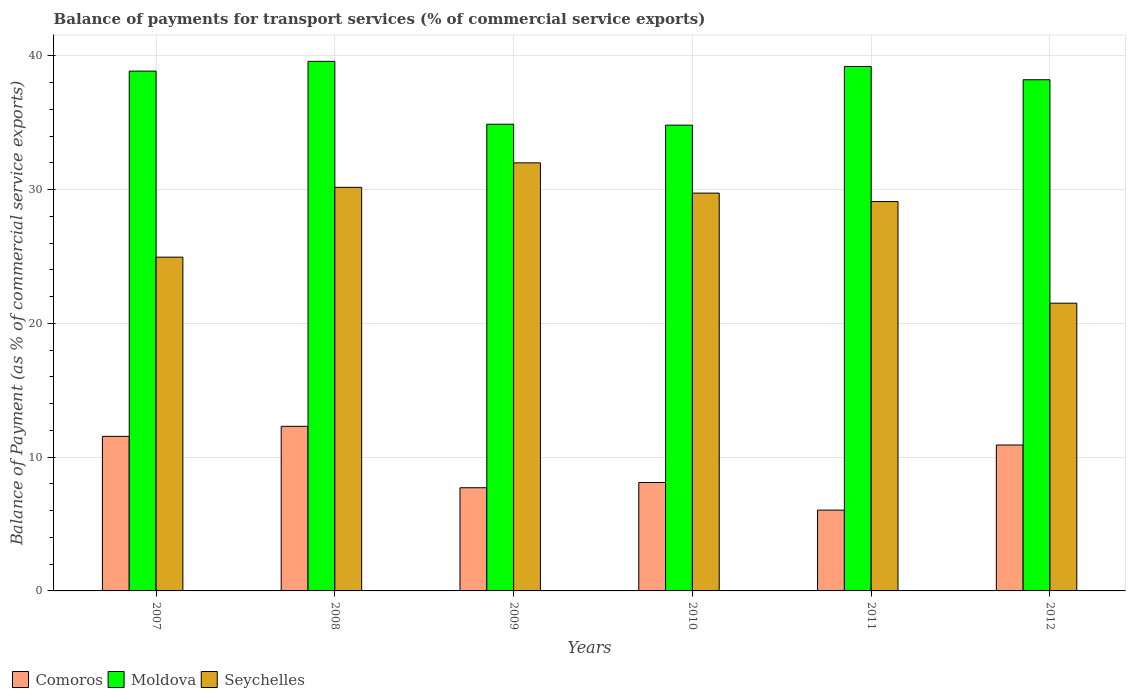How many different coloured bars are there?
Your answer should be compact. 3. How many bars are there on the 3rd tick from the left?
Your answer should be very brief. 3. What is the label of the 4th group of bars from the left?
Your answer should be compact. 2010. What is the balance of payments for transport services in Comoros in 2009?
Your answer should be very brief. 7.71. Across all years, what is the maximum balance of payments for transport services in Seychelles?
Offer a very short reply. 32. Across all years, what is the minimum balance of payments for transport services in Comoros?
Give a very brief answer. 6.04. In which year was the balance of payments for transport services in Moldova maximum?
Offer a terse response. 2008. What is the total balance of payments for transport services in Seychelles in the graph?
Give a very brief answer. 167.48. What is the difference between the balance of payments for transport services in Moldova in 2010 and that in 2011?
Your response must be concise. -4.39. What is the difference between the balance of payments for transport services in Moldova in 2008 and the balance of payments for transport services in Seychelles in 2009?
Your answer should be very brief. 7.59. What is the average balance of payments for transport services in Comoros per year?
Make the answer very short. 9.44. In the year 2012, what is the difference between the balance of payments for transport services in Seychelles and balance of payments for transport services in Moldova?
Your answer should be compact. -16.7. In how many years, is the balance of payments for transport services in Moldova greater than 4 %?
Provide a succinct answer. 6. What is the ratio of the balance of payments for transport services in Comoros in 2009 to that in 2011?
Provide a short and direct response. 1.28. What is the difference between the highest and the second highest balance of payments for transport services in Comoros?
Ensure brevity in your answer.  0.75. What is the difference between the highest and the lowest balance of payments for transport services in Comoros?
Give a very brief answer. 6.26. In how many years, is the balance of payments for transport services in Moldova greater than the average balance of payments for transport services in Moldova taken over all years?
Make the answer very short. 4. What does the 3rd bar from the left in 2010 represents?
Give a very brief answer. Seychelles. What does the 3rd bar from the right in 2012 represents?
Provide a short and direct response. Comoros. How many bars are there?
Your answer should be compact. 18. How many years are there in the graph?
Provide a short and direct response. 6. What is the difference between two consecutive major ticks on the Y-axis?
Your response must be concise. 10. Are the values on the major ticks of Y-axis written in scientific E-notation?
Your response must be concise. No. Does the graph contain any zero values?
Keep it short and to the point. No. Does the graph contain grids?
Offer a terse response. Yes. Where does the legend appear in the graph?
Provide a short and direct response. Bottom left. How many legend labels are there?
Ensure brevity in your answer.  3. What is the title of the graph?
Offer a terse response. Balance of payments for transport services (% of commercial service exports). What is the label or title of the X-axis?
Your response must be concise. Years. What is the label or title of the Y-axis?
Make the answer very short. Balance of Payment (as % of commercial service exports). What is the Balance of Payment (as % of commercial service exports) of Comoros in 2007?
Offer a terse response. 11.56. What is the Balance of Payment (as % of commercial service exports) of Moldova in 2007?
Ensure brevity in your answer.  38.86. What is the Balance of Payment (as % of commercial service exports) of Seychelles in 2007?
Make the answer very short. 24.95. What is the Balance of Payment (as % of commercial service exports) of Comoros in 2008?
Your answer should be very brief. 12.31. What is the Balance of Payment (as % of commercial service exports) in Moldova in 2008?
Provide a short and direct response. 39.59. What is the Balance of Payment (as % of commercial service exports) of Seychelles in 2008?
Your response must be concise. 30.17. What is the Balance of Payment (as % of commercial service exports) of Comoros in 2009?
Offer a terse response. 7.71. What is the Balance of Payment (as % of commercial service exports) in Moldova in 2009?
Keep it short and to the point. 34.89. What is the Balance of Payment (as % of commercial service exports) in Seychelles in 2009?
Ensure brevity in your answer.  32. What is the Balance of Payment (as % of commercial service exports) in Comoros in 2010?
Your answer should be very brief. 8.1. What is the Balance of Payment (as % of commercial service exports) of Moldova in 2010?
Your answer should be very brief. 34.82. What is the Balance of Payment (as % of commercial service exports) of Seychelles in 2010?
Provide a succinct answer. 29.74. What is the Balance of Payment (as % of commercial service exports) of Comoros in 2011?
Your answer should be very brief. 6.04. What is the Balance of Payment (as % of commercial service exports) of Moldova in 2011?
Offer a very short reply. 39.21. What is the Balance of Payment (as % of commercial service exports) in Seychelles in 2011?
Provide a succinct answer. 29.11. What is the Balance of Payment (as % of commercial service exports) in Comoros in 2012?
Provide a succinct answer. 10.91. What is the Balance of Payment (as % of commercial service exports) in Moldova in 2012?
Make the answer very short. 38.22. What is the Balance of Payment (as % of commercial service exports) of Seychelles in 2012?
Provide a short and direct response. 21.51. Across all years, what is the maximum Balance of Payment (as % of commercial service exports) of Comoros?
Give a very brief answer. 12.31. Across all years, what is the maximum Balance of Payment (as % of commercial service exports) of Moldova?
Give a very brief answer. 39.59. Across all years, what is the maximum Balance of Payment (as % of commercial service exports) of Seychelles?
Your answer should be compact. 32. Across all years, what is the minimum Balance of Payment (as % of commercial service exports) of Comoros?
Provide a succinct answer. 6.04. Across all years, what is the minimum Balance of Payment (as % of commercial service exports) in Moldova?
Provide a succinct answer. 34.82. Across all years, what is the minimum Balance of Payment (as % of commercial service exports) of Seychelles?
Keep it short and to the point. 21.51. What is the total Balance of Payment (as % of commercial service exports) in Comoros in the graph?
Make the answer very short. 56.63. What is the total Balance of Payment (as % of commercial service exports) in Moldova in the graph?
Your answer should be very brief. 225.59. What is the total Balance of Payment (as % of commercial service exports) in Seychelles in the graph?
Your answer should be very brief. 167.48. What is the difference between the Balance of Payment (as % of commercial service exports) in Comoros in 2007 and that in 2008?
Your answer should be compact. -0.75. What is the difference between the Balance of Payment (as % of commercial service exports) in Moldova in 2007 and that in 2008?
Make the answer very short. -0.73. What is the difference between the Balance of Payment (as % of commercial service exports) in Seychelles in 2007 and that in 2008?
Ensure brevity in your answer.  -5.22. What is the difference between the Balance of Payment (as % of commercial service exports) of Comoros in 2007 and that in 2009?
Keep it short and to the point. 3.84. What is the difference between the Balance of Payment (as % of commercial service exports) of Moldova in 2007 and that in 2009?
Your response must be concise. 3.97. What is the difference between the Balance of Payment (as % of commercial service exports) of Seychelles in 2007 and that in 2009?
Make the answer very short. -7.05. What is the difference between the Balance of Payment (as % of commercial service exports) in Comoros in 2007 and that in 2010?
Keep it short and to the point. 3.45. What is the difference between the Balance of Payment (as % of commercial service exports) in Moldova in 2007 and that in 2010?
Make the answer very short. 4.04. What is the difference between the Balance of Payment (as % of commercial service exports) of Seychelles in 2007 and that in 2010?
Give a very brief answer. -4.79. What is the difference between the Balance of Payment (as % of commercial service exports) of Comoros in 2007 and that in 2011?
Offer a terse response. 5.51. What is the difference between the Balance of Payment (as % of commercial service exports) in Moldova in 2007 and that in 2011?
Offer a terse response. -0.35. What is the difference between the Balance of Payment (as % of commercial service exports) of Seychelles in 2007 and that in 2011?
Ensure brevity in your answer.  -4.16. What is the difference between the Balance of Payment (as % of commercial service exports) in Comoros in 2007 and that in 2012?
Your response must be concise. 0.65. What is the difference between the Balance of Payment (as % of commercial service exports) in Moldova in 2007 and that in 2012?
Offer a terse response. 0.65. What is the difference between the Balance of Payment (as % of commercial service exports) in Seychelles in 2007 and that in 2012?
Offer a terse response. 3.44. What is the difference between the Balance of Payment (as % of commercial service exports) in Comoros in 2008 and that in 2009?
Provide a succinct answer. 4.59. What is the difference between the Balance of Payment (as % of commercial service exports) of Moldova in 2008 and that in 2009?
Provide a succinct answer. 4.7. What is the difference between the Balance of Payment (as % of commercial service exports) of Seychelles in 2008 and that in 2009?
Your answer should be compact. -1.83. What is the difference between the Balance of Payment (as % of commercial service exports) of Comoros in 2008 and that in 2010?
Provide a short and direct response. 4.2. What is the difference between the Balance of Payment (as % of commercial service exports) of Moldova in 2008 and that in 2010?
Keep it short and to the point. 4.77. What is the difference between the Balance of Payment (as % of commercial service exports) of Seychelles in 2008 and that in 2010?
Offer a very short reply. 0.43. What is the difference between the Balance of Payment (as % of commercial service exports) of Comoros in 2008 and that in 2011?
Make the answer very short. 6.26. What is the difference between the Balance of Payment (as % of commercial service exports) of Moldova in 2008 and that in 2011?
Make the answer very short. 0.38. What is the difference between the Balance of Payment (as % of commercial service exports) in Seychelles in 2008 and that in 2011?
Your response must be concise. 1.06. What is the difference between the Balance of Payment (as % of commercial service exports) in Comoros in 2008 and that in 2012?
Offer a terse response. 1.4. What is the difference between the Balance of Payment (as % of commercial service exports) of Moldova in 2008 and that in 2012?
Your response must be concise. 1.37. What is the difference between the Balance of Payment (as % of commercial service exports) of Seychelles in 2008 and that in 2012?
Your response must be concise. 8.66. What is the difference between the Balance of Payment (as % of commercial service exports) in Comoros in 2009 and that in 2010?
Offer a terse response. -0.39. What is the difference between the Balance of Payment (as % of commercial service exports) of Moldova in 2009 and that in 2010?
Keep it short and to the point. 0.07. What is the difference between the Balance of Payment (as % of commercial service exports) in Seychelles in 2009 and that in 2010?
Offer a terse response. 2.26. What is the difference between the Balance of Payment (as % of commercial service exports) of Comoros in 2009 and that in 2011?
Offer a very short reply. 1.67. What is the difference between the Balance of Payment (as % of commercial service exports) of Moldova in 2009 and that in 2011?
Your answer should be very brief. -4.32. What is the difference between the Balance of Payment (as % of commercial service exports) of Seychelles in 2009 and that in 2011?
Give a very brief answer. 2.89. What is the difference between the Balance of Payment (as % of commercial service exports) in Comoros in 2009 and that in 2012?
Give a very brief answer. -3.19. What is the difference between the Balance of Payment (as % of commercial service exports) of Moldova in 2009 and that in 2012?
Make the answer very short. -3.33. What is the difference between the Balance of Payment (as % of commercial service exports) in Seychelles in 2009 and that in 2012?
Your answer should be very brief. 10.49. What is the difference between the Balance of Payment (as % of commercial service exports) in Comoros in 2010 and that in 2011?
Your response must be concise. 2.06. What is the difference between the Balance of Payment (as % of commercial service exports) of Moldova in 2010 and that in 2011?
Make the answer very short. -4.39. What is the difference between the Balance of Payment (as % of commercial service exports) in Seychelles in 2010 and that in 2011?
Keep it short and to the point. 0.63. What is the difference between the Balance of Payment (as % of commercial service exports) in Comoros in 2010 and that in 2012?
Offer a very short reply. -2.8. What is the difference between the Balance of Payment (as % of commercial service exports) of Moldova in 2010 and that in 2012?
Ensure brevity in your answer.  -3.39. What is the difference between the Balance of Payment (as % of commercial service exports) in Seychelles in 2010 and that in 2012?
Offer a terse response. 8.23. What is the difference between the Balance of Payment (as % of commercial service exports) in Comoros in 2011 and that in 2012?
Provide a succinct answer. -4.87. What is the difference between the Balance of Payment (as % of commercial service exports) in Moldova in 2011 and that in 2012?
Make the answer very short. 0.99. What is the difference between the Balance of Payment (as % of commercial service exports) of Seychelles in 2011 and that in 2012?
Your answer should be very brief. 7.6. What is the difference between the Balance of Payment (as % of commercial service exports) in Comoros in 2007 and the Balance of Payment (as % of commercial service exports) in Moldova in 2008?
Provide a succinct answer. -28.03. What is the difference between the Balance of Payment (as % of commercial service exports) in Comoros in 2007 and the Balance of Payment (as % of commercial service exports) in Seychelles in 2008?
Give a very brief answer. -18.62. What is the difference between the Balance of Payment (as % of commercial service exports) in Moldova in 2007 and the Balance of Payment (as % of commercial service exports) in Seychelles in 2008?
Provide a succinct answer. 8.69. What is the difference between the Balance of Payment (as % of commercial service exports) of Comoros in 2007 and the Balance of Payment (as % of commercial service exports) of Moldova in 2009?
Give a very brief answer. -23.33. What is the difference between the Balance of Payment (as % of commercial service exports) of Comoros in 2007 and the Balance of Payment (as % of commercial service exports) of Seychelles in 2009?
Your answer should be compact. -20.45. What is the difference between the Balance of Payment (as % of commercial service exports) of Moldova in 2007 and the Balance of Payment (as % of commercial service exports) of Seychelles in 2009?
Provide a succinct answer. 6.86. What is the difference between the Balance of Payment (as % of commercial service exports) of Comoros in 2007 and the Balance of Payment (as % of commercial service exports) of Moldova in 2010?
Your answer should be compact. -23.27. What is the difference between the Balance of Payment (as % of commercial service exports) in Comoros in 2007 and the Balance of Payment (as % of commercial service exports) in Seychelles in 2010?
Offer a terse response. -18.18. What is the difference between the Balance of Payment (as % of commercial service exports) of Moldova in 2007 and the Balance of Payment (as % of commercial service exports) of Seychelles in 2010?
Your answer should be compact. 9.12. What is the difference between the Balance of Payment (as % of commercial service exports) of Comoros in 2007 and the Balance of Payment (as % of commercial service exports) of Moldova in 2011?
Provide a short and direct response. -27.65. What is the difference between the Balance of Payment (as % of commercial service exports) in Comoros in 2007 and the Balance of Payment (as % of commercial service exports) in Seychelles in 2011?
Keep it short and to the point. -17.55. What is the difference between the Balance of Payment (as % of commercial service exports) in Moldova in 2007 and the Balance of Payment (as % of commercial service exports) in Seychelles in 2011?
Your answer should be very brief. 9.75. What is the difference between the Balance of Payment (as % of commercial service exports) in Comoros in 2007 and the Balance of Payment (as % of commercial service exports) in Moldova in 2012?
Your answer should be compact. -26.66. What is the difference between the Balance of Payment (as % of commercial service exports) in Comoros in 2007 and the Balance of Payment (as % of commercial service exports) in Seychelles in 2012?
Your answer should be compact. -9.96. What is the difference between the Balance of Payment (as % of commercial service exports) of Moldova in 2007 and the Balance of Payment (as % of commercial service exports) of Seychelles in 2012?
Provide a short and direct response. 17.35. What is the difference between the Balance of Payment (as % of commercial service exports) in Comoros in 2008 and the Balance of Payment (as % of commercial service exports) in Moldova in 2009?
Keep it short and to the point. -22.58. What is the difference between the Balance of Payment (as % of commercial service exports) in Comoros in 2008 and the Balance of Payment (as % of commercial service exports) in Seychelles in 2009?
Offer a terse response. -19.7. What is the difference between the Balance of Payment (as % of commercial service exports) of Moldova in 2008 and the Balance of Payment (as % of commercial service exports) of Seychelles in 2009?
Offer a terse response. 7.59. What is the difference between the Balance of Payment (as % of commercial service exports) of Comoros in 2008 and the Balance of Payment (as % of commercial service exports) of Moldova in 2010?
Offer a terse response. -22.52. What is the difference between the Balance of Payment (as % of commercial service exports) in Comoros in 2008 and the Balance of Payment (as % of commercial service exports) in Seychelles in 2010?
Give a very brief answer. -17.43. What is the difference between the Balance of Payment (as % of commercial service exports) of Moldova in 2008 and the Balance of Payment (as % of commercial service exports) of Seychelles in 2010?
Your response must be concise. 9.85. What is the difference between the Balance of Payment (as % of commercial service exports) in Comoros in 2008 and the Balance of Payment (as % of commercial service exports) in Moldova in 2011?
Keep it short and to the point. -26.9. What is the difference between the Balance of Payment (as % of commercial service exports) of Comoros in 2008 and the Balance of Payment (as % of commercial service exports) of Seychelles in 2011?
Offer a terse response. -16.8. What is the difference between the Balance of Payment (as % of commercial service exports) of Moldova in 2008 and the Balance of Payment (as % of commercial service exports) of Seychelles in 2011?
Ensure brevity in your answer.  10.48. What is the difference between the Balance of Payment (as % of commercial service exports) of Comoros in 2008 and the Balance of Payment (as % of commercial service exports) of Moldova in 2012?
Offer a very short reply. -25.91. What is the difference between the Balance of Payment (as % of commercial service exports) of Comoros in 2008 and the Balance of Payment (as % of commercial service exports) of Seychelles in 2012?
Give a very brief answer. -9.21. What is the difference between the Balance of Payment (as % of commercial service exports) of Moldova in 2008 and the Balance of Payment (as % of commercial service exports) of Seychelles in 2012?
Your response must be concise. 18.08. What is the difference between the Balance of Payment (as % of commercial service exports) in Comoros in 2009 and the Balance of Payment (as % of commercial service exports) in Moldova in 2010?
Your answer should be very brief. -27.11. What is the difference between the Balance of Payment (as % of commercial service exports) of Comoros in 2009 and the Balance of Payment (as % of commercial service exports) of Seychelles in 2010?
Your answer should be very brief. -22.03. What is the difference between the Balance of Payment (as % of commercial service exports) of Moldova in 2009 and the Balance of Payment (as % of commercial service exports) of Seychelles in 2010?
Offer a very short reply. 5.15. What is the difference between the Balance of Payment (as % of commercial service exports) in Comoros in 2009 and the Balance of Payment (as % of commercial service exports) in Moldova in 2011?
Give a very brief answer. -31.49. What is the difference between the Balance of Payment (as % of commercial service exports) in Comoros in 2009 and the Balance of Payment (as % of commercial service exports) in Seychelles in 2011?
Your response must be concise. -21.4. What is the difference between the Balance of Payment (as % of commercial service exports) of Moldova in 2009 and the Balance of Payment (as % of commercial service exports) of Seychelles in 2011?
Give a very brief answer. 5.78. What is the difference between the Balance of Payment (as % of commercial service exports) of Comoros in 2009 and the Balance of Payment (as % of commercial service exports) of Moldova in 2012?
Your answer should be compact. -30.5. What is the difference between the Balance of Payment (as % of commercial service exports) of Comoros in 2009 and the Balance of Payment (as % of commercial service exports) of Seychelles in 2012?
Give a very brief answer. -13.8. What is the difference between the Balance of Payment (as % of commercial service exports) in Moldova in 2009 and the Balance of Payment (as % of commercial service exports) in Seychelles in 2012?
Make the answer very short. 13.38. What is the difference between the Balance of Payment (as % of commercial service exports) of Comoros in 2010 and the Balance of Payment (as % of commercial service exports) of Moldova in 2011?
Offer a very short reply. -31.1. What is the difference between the Balance of Payment (as % of commercial service exports) in Comoros in 2010 and the Balance of Payment (as % of commercial service exports) in Seychelles in 2011?
Your answer should be compact. -21. What is the difference between the Balance of Payment (as % of commercial service exports) of Moldova in 2010 and the Balance of Payment (as % of commercial service exports) of Seychelles in 2011?
Provide a short and direct response. 5.71. What is the difference between the Balance of Payment (as % of commercial service exports) in Comoros in 2010 and the Balance of Payment (as % of commercial service exports) in Moldova in 2012?
Your response must be concise. -30.11. What is the difference between the Balance of Payment (as % of commercial service exports) in Comoros in 2010 and the Balance of Payment (as % of commercial service exports) in Seychelles in 2012?
Provide a short and direct response. -13.41. What is the difference between the Balance of Payment (as % of commercial service exports) of Moldova in 2010 and the Balance of Payment (as % of commercial service exports) of Seychelles in 2012?
Provide a succinct answer. 13.31. What is the difference between the Balance of Payment (as % of commercial service exports) in Comoros in 2011 and the Balance of Payment (as % of commercial service exports) in Moldova in 2012?
Ensure brevity in your answer.  -32.17. What is the difference between the Balance of Payment (as % of commercial service exports) of Comoros in 2011 and the Balance of Payment (as % of commercial service exports) of Seychelles in 2012?
Provide a short and direct response. -15.47. What is the difference between the Balance of Payment (as % of commercial service exports) in Moldova in 2011 and the Balance of Payment (as % of commercial service exports) in Seychelles in 2012?
Your response must be concise. 17.7. What is the average Balance of Payment (as % of commercial service exports) of Comoros per year?
Provide a succinct answer. 9.44. What is the average Balance of Payment (as % of commercial service exports) of Moldova per year?
Your answer should be very brief. 37.6. What is the average Balance of Payment (as % of commercial service exports) in Seychelles per year?
Your answer should be very brief. 27.91. In the year 2007, what is the difference between the Balance of Payment (as % of commercial service exports) in Comoros and Balance of Payment (as % of commercial service exports) in Moldova?
Provide a short and direct response. -27.31. In the year 2007, what is the difference between the Balance of Payment (as % of commercial service exports) in Comoros and Balance of Payment (as % of commercial service exports) in Seychelles?
Provide a short and direct response. -13.4. In the year 2007, what is the difference between the Balance of Payment (as % of commercial service exports) in Moldova and Balance of Payment (as % of commercial service exports) in Seychelles?
Your response must be concise. 13.91. In the year 2008, what is the difference between the Balance of Payment (as % of commercial service exports) in Comoros and Balance of Payment (as % of commercial service exports) in Moldova?
Offer a very short reply. -27.28. In the year 2008, what is the difference between the Balance of Payment (as % of commercial service exports) of Comoros and Balance of Payment (as % of commercial service exports) of Seychelles?
Your response must be concise. -17.87. In the year 2008, what is the difference between the Balance of Payment (as % of commercial service exports) in Moldova and Balance of Payment (as % of commercial service exports) in Seychelles?
Your answer should be very brief. 9.42. In the year 2009, what is the difference between the Balance of Payment (as % of commercial service exports) in Comoros and Balance of Payment (as % of commercial service exports) in Moldova?
Give a very brief answer. -27.18. In the year 2009, what is the difference between the Balance of Payment (as % of commercial service exports) in Comoros and Balance of Payment (as % of commercial service exports) in Seychelles?
Give a very brief answer. -24.29. In the year 2009, what is the difference between the Balance of Payment (as % of commercial service exports) in Moldova and Balance of Payment (as % of commercial service exports) in Seychelles?
Offer a terse response. 2.89. In the year 2010, what is the difference between the Balance of Payment (as % of commercial service exports) in Comoros and Balance of Payment (as % of commercial service exports) in Moldova?
Offer a terse response. -26.72. In the year 2010, what is the difference between the Balance of Payment (as % of commercial service exports) in Comoros and Balance of Payment (as % of commercial service exports) in Seychelles?
Ensure brevity in your answer.  -21.63. In the year 2010, what is the difference between the Balance of Payment (as % of commercial service exports) in Moldova and Balance of Payment (as % of commercial service exports) in Seychelles?
Keep it short and to the point. 5.08. In the year 2011, what is the difference between the Balance of Payment (as % of commercial service exports) of Comoros and Balance of Payment (as % of commercial service exports) of Moldova?
Your answer should be compact. -33.17. In the year 2011, what is the difference between the Balance of Payment (as % of commercial service exports) in Comoros and Balance of Payment (as % of commercial service exports) in Seychelles?
Your answer should be very brief. -23.07. In the year 2011, what is the difference between the Balance of Payment (as % of commercial service exports) of Moldova and Balance of Payment (as % of commercial service exports) of Seychelles?
Make the answer very short. 10.1. In the year 2012, what is the difference between the Balance of Payment (as % of commercial service exports) of Comoros and Balance of Payment (as % of commercial service exports) of Moldova?
Your answer should be compact. -27.31. In the year 2012, what is the difference between the Balance of Payment (as % of commercial service exports) of Comoros and Balance of Payment (as % of commercial service exports) of Seychelles?
Your answer should be compact. -10.6. In the year 2012, what is the difference between the Balance of Payment (as % of commercial service exports) in Moldova and Balance of Payment (as % of commercial service exports) in Seychelles?
Offer a very short reply. 16.7. What is the ratio of the Balance of Payment (as % of commercial service exports) of Comoros in 2007 to that in 2008?
Provide a short and direct response. 0.94. What is the ratio of the Balance of Payment (as % of commercial service exports) of Moldova in 2007 to that in 2008?
Keep it short and to the point. 0.98. What is the ratio of the Balance of Payment (as % of commercial service exports) in Seychelles in 2007 to that in 2008?
Offer a terse response. 0.83. What is the ratio of the Balance of Payment (as % of commercial service exports) of Comoros in 2007 to that in 2009?
Keep it short and to the point. 1.5. What is the ratio of the Balance of Payment (as % of commercial service exports) in Moldova in 2007 to that in 2009?
Provide a short and direct response. 1.11. What is the ratio of the Balance of Payment (as % of commercial service exports) of Seychelles in 2007 to that in 2009?
Your answer should be very brief. 0.78. What is the ratio of the Balance of Payment (as % of commercial service exports) of Comoros in 2007 to that in 2010?
Ensure brevity in your answer.  1.43. What is the ratio of the Balance of Payment (as % of commercial service exports) of Moldova in 2007 to that in 2010?
Keep it short and to the point. 1.12. What is the ratio of the Balance of Payment (as % of commercial service exports) of Seychelles in 2007 to that in 2010?
Provide a succinct answer. 0.84. What is the ratio of the Balance of Payment (as % of commercial service exports) in Comoros in 2007 to that in 2011?
Provide a short and direct response. 1.91. What is the ratio of the Balance of Payment (as % of commercial service exports) of Moldova in 2007 to that in 2011?
Your answer should be compact. 0.99. What is the ratio of the Balance of Payment (as % of commercial service exports) in Seychelles in 2007 to that in 2011?
Your response must be concise. 0.86. What is the ratio of the Balance of Payment (as % of commercial service exports) of Comoros in 2007 to that in 2012?
Your response must be concise. 1.06. What is the ratio of the Balance of Payment (as % of commercial service exports) of Moldova in 2007 to that in 2012?
Offer a terse response. 1.02. What is the ratio of the Balance of Payment (as % of commercial service exports) in Seychelles in 2007 to that in 2012?
Ensure brevity in your answer.  1.16. What is the ratio of the Balance of Payment (as % of commercial service exports) of Comoros in 2008 to that in 2009?
Your response must be concise. 1.6. What is the ratio of the Balance of Payment (as % of commercial service exports) of Moldova in 2008 to that in 2009?
Your response must be concise. 1.13. What is the ratio of the Balance of Payment (as % of commercial service exports) in Seychelles in 2008 to that in 2009?
Offer a terse response. 0.94. What is the ratio of the Balance of Payment (as % of commercial service exports) in Comoros in 2008 to that in 2010?
Offer a very short reply. 1.52. What is the ratio of the Balance of Payment (as % of commercial service exports) of Moldova in 2008 to that in 2010?
Offer a very short reply. 1.14. What is the ratio of the Balance of Payment (as % of commercial service exports) of Seychelles in 2008 to that in 2010?
Your answer should be very brief. 1.01. What is the ratio of the Balance of Payment (as % of commercial service exports) in Comoros in 2008 to that in 2011?
Keep it short and to the point. 2.04. What is the ratio of the Balance of Payment (as % of commercial service exports) of Moldova in 2008 to that in 2011?
Make the answer very short. 1.01. What is the ratio of the Balance of Payment (as % of commercial service exports) of Seychelles in 2008 to that in 2011?
Your answer should be very brief. 1.04. What is the ratio of the Balance of Payment (as % of commercial service exports) in Comoros in 2008 to that in 2012?
Ensure brevity in your answer.  1.13. What is the ratio of the Balance of Payment (as % of commercial service exports) of Moldova in 2008 to that in 2012?
Keep it short and to the point. 1.04. What is the ratio of the Balance of Payment (as % of commercial service exports) of Seychelles in 2008 to that in 2012?
Your response must be concise. 1.4. What is the ratio of the Balance of Payment (as % of commercial service exports) of Comoros in 2009 to that in 2010?
Provide a short and direct response. 0.95. What is the ratio of the Balance of Payment (as % of commercial service exports) in Moldova in 2009 to that in 2010?
Your response must be concise. 1. What is the ratio of the Balance of Payment (as % of commercial service exports) of Seychelles in 2009 to that in 2010?
Your answer should be compact. 1.08. What is the ratio of the Balance of Payment (as % of commercial service exports) in Comoros in 2009 to that in 2011?
Provide a short and direct response. 1.28. What is the ratio of the Balance of Payment (as % of commercial service exports) in Moldova in 2009 to that in 2011?
Make the answer very short. 0.89. What is the ratio of the Balance of Payment (as % of commercial service exports) of Seychelles in 2009 to that in 2011?
Offer a terse response. 1.1. What is the ratio of the Balance of Payment (as % of commercial service exports) in Comoros in 2009 to that in 2012?
Provide a succinct answer. 0.71. What is the ratio of the Balance of Payment (as % of commercial service exports) of Moldova in 2009 to that in 2012?
Provide a short and direct response. 0.91. What is the ratio of the Balance of Payment (as % of commercial service exports) in Seychelles in 2009 to that in 2012?
Make the answer very short. 1.49. What is the ratio of the Balance of Payment (as % of commercial service exports) in Comoros in 2010 to that in 2011?
Ensure brevity in your answer.  1.34. What is the ratio of the Balance of Payment (as % of commercial service exports) of Moldova in 2010 to that in 2011?
Provide a succinct answer. 0.89. What is the ratio of the Balance of Payment (as % of commercial service exports) in Seychelles in 2010 to that in 2011?
Offer a very short reply. 1.02. What is the ratio of the Balance of Payment (as % of commercial service exports) in Comoros in 2010 to that in 2012?
Keep it short and to the point. 0.74. What is the ratio of the Balance of Payment (as % of commercial service exports) in Moldova in 2010 to that in 2012?
Provide a succinct answer. 0.91. What is the ratio of the Balance of Payment (as % of commercial service exports) of Seychelles in 2010 to that in 2012?
Provide a succinct answer. 1.38. What is the ratio of the Balance of Payment (as % of commercial service exports) of Comoros in 2011 to that in 2012?
Offer a terse response. 0.55. What is the ratio of the Balance of Payment (as % of commercial service exports) of Moldova in 2011 to that in 2012?
Provide a succinct answer. 1.03. What is the ratio of the Balance of Payment (as % of commercial service exports) of Seychelles in 2011 to that in 2012?
Offer a very short reply. 1.35. What is the difference between the highest and the second highest Balance of Payment (as % of commercial service exports) in Comoros?
Your response must be concise. 0.75. What is the difference between the highest and the second highest Balance of Payment (as % of commercial service exports) of Moldova?
Offer a very short reply. 0.38. What is the difference between the highest and the second highest Balance of Payment (as % of commercial service exports) of Seychelles?
Provide a succinct answer. 1.83. What is the difference between the highest and the lowest Balance of Payment (as % of commercial service exports) in Comoros?
Your answer should be very brief. 6.26. What is the difference between the highest and the lowest Balance of Payment (as % of commercial service exports) of Moldova?
Give a very brief answer. 4.77. What is the difference between the highest and the lowest Balance of Payment (as % of commercial service exports) of Seychelles?
Offer a terse response. 10.49. 